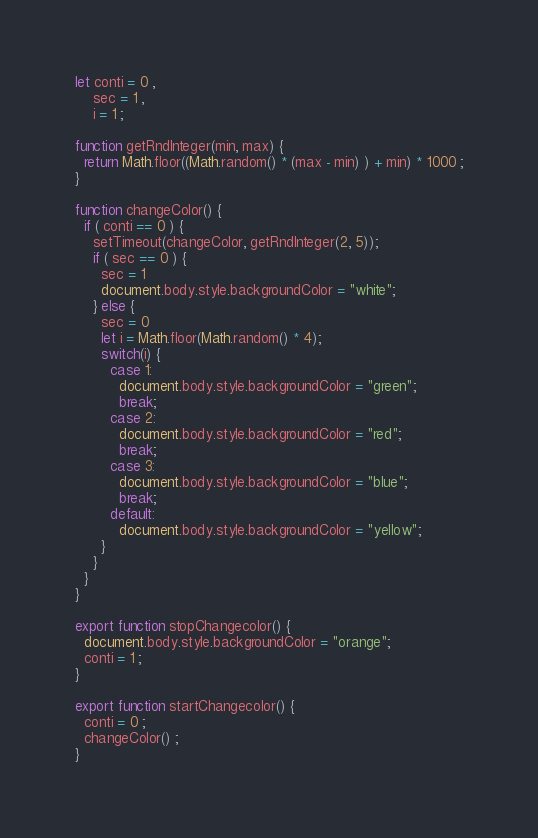Convert code to text. <code><loc_0><loc_0><loc_500><loc_500><_JavaScript_>let conti = 0 ,
    sec = 1 ,
    i = 1 ;

function getRndInteger(min, max) {
  return Math.floor((Math.random() * (max - min) ) + min) * 1000 ;
}

function changeColor() {
  if ( conti == 0 ) { 
    setTimeout(changeColor, getRndInteger(2, 5)); 
    if ( sec == 0 ) { 
      sec = 1
      document.body.style.backgroundColor = "white"; 
    } else { 
      sec = 0 
      let i = Math.floor(Math.random() * 4);
      switch(i) {
        case 1:
          document.body.style.backgroundColor = "green"; 
          break;
        case 2:
          document.body.style.backgroundColor = "red"; 
          break;
        case 3:
          document.body.style.backgroundColor = "blue"; 
          break;	  
        default:
          document.body.style.backgroundColor = "yellow"; 
      }
    }
  } 
}

export function stopChangecolor() {
  document.body.style.backgroundColor = "orange";  
  conti = 1 ;
}

export function startChangecolor() {
  conti = 0 ;
  changeColor() ;  
}
</code> 